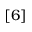<formula> <loc_0><loc_0><loc_500><loc_500>[ 6 ]</formula> 